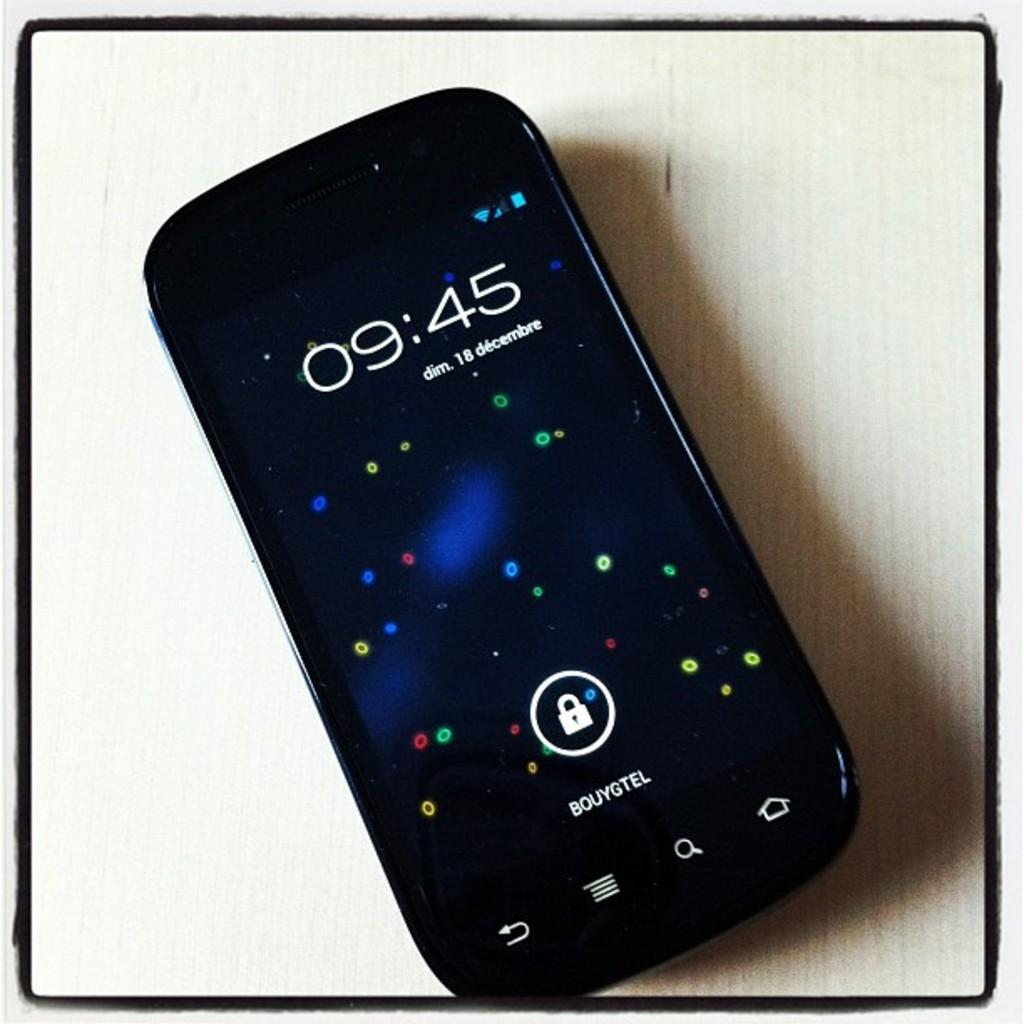<image>
Share a concise interpretation of the image provided. A smartphone shows the time as 9:45, the service provider is bouygtel. 